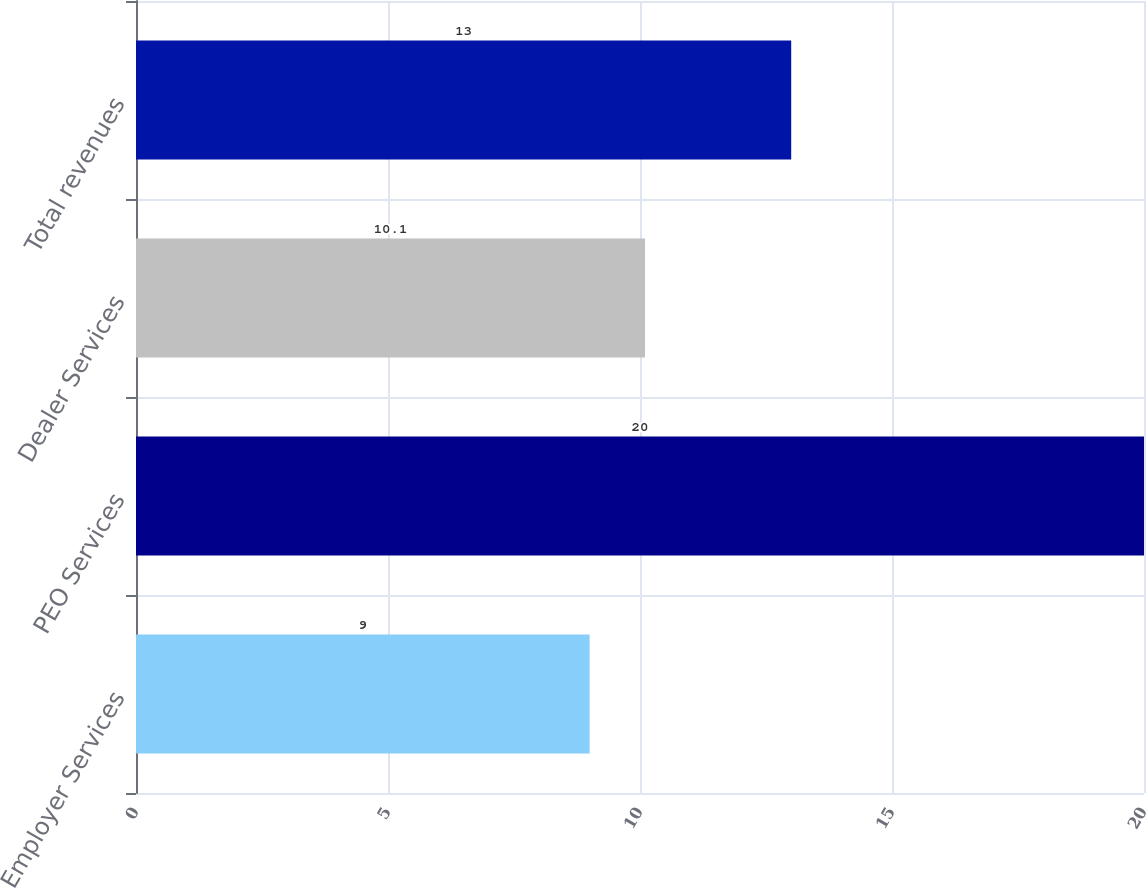Convert chart. <chart><loc_0><loc_0><loc_500><loc_500><bar_chart><fcel>Employer Services<fcel>PEO Services<fcel>Dealer Services<fcel>Total revenues<nl><fcel>9<fcel>20<fcel>10.1<fcel>13<nl></chart> 